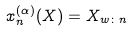<formula> <loc_0><loc_0><loc_500><loc_500>x _ { n } ^ { ( \alpha ) } ( X ) = X _ { w \colon n }</formula> 